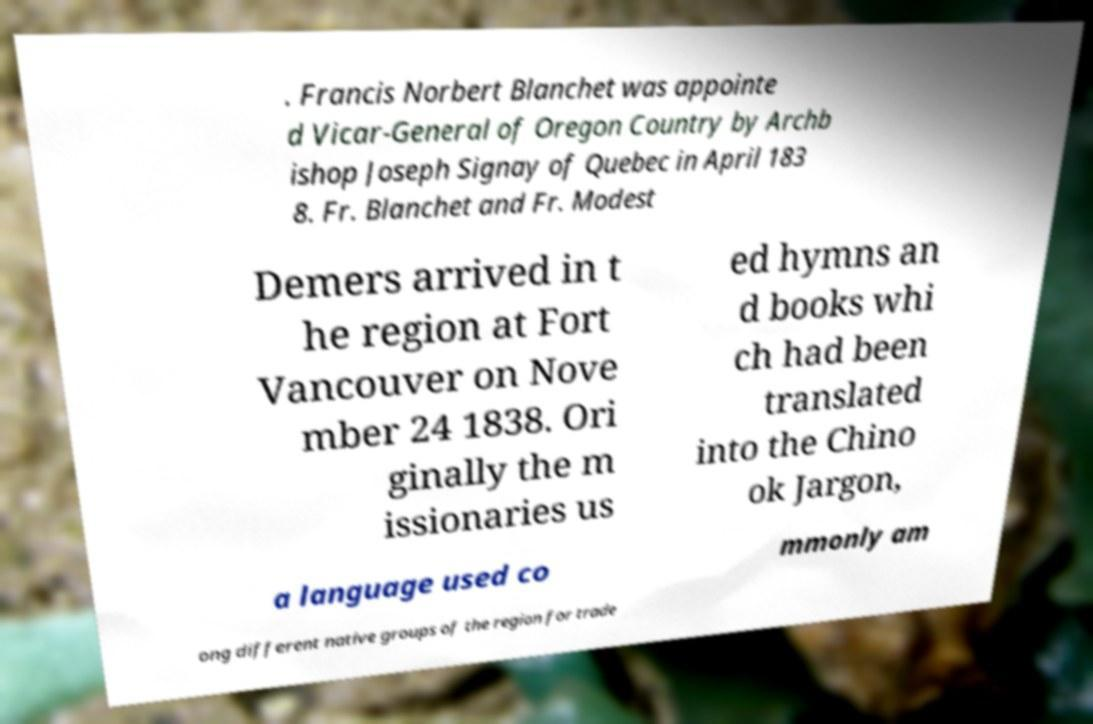Please read and relay the text visible in this image. What does it say? . Francis Norbert Blanchet was appointe d Vicar-General of Oregon Country by Archb ishop Joseph Signay of Quebec in April 183 8. Fr. Blanchet and Fr. Modest Demers arrived in t he region at Fort Vancouver on Nove mber 24 1838. Ori ginally the m issionaries us ed hymns an d books whi ch had been translated into the Chino ok Jargon, a language used co mmonly am ong different native groups of the region for trade 